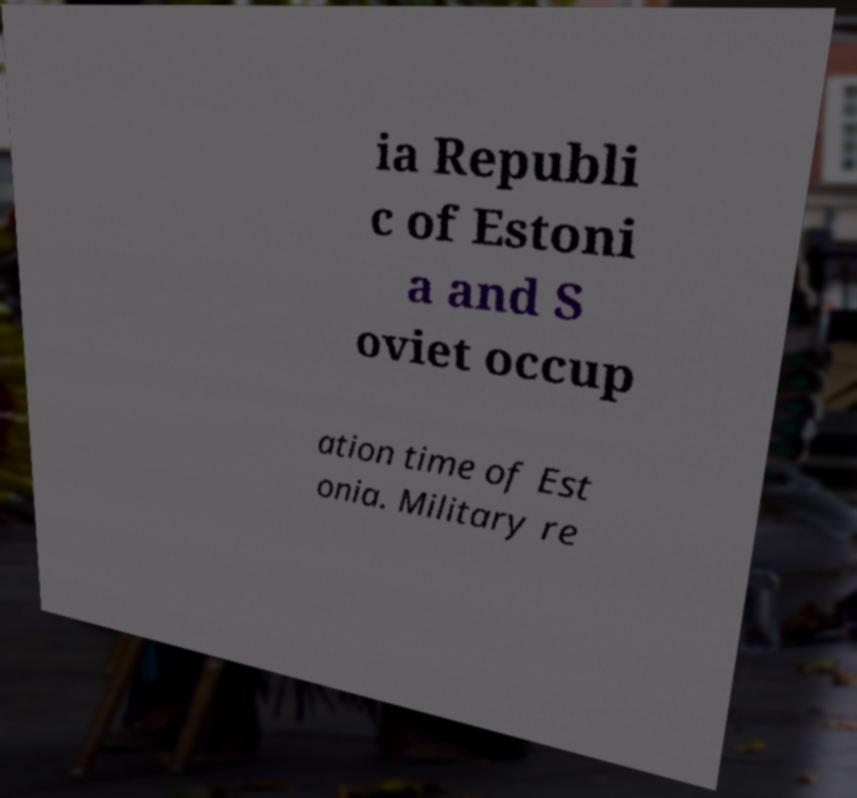For documentation purposes, I need the text within this image transcribed. Could you provide that? ia Republi c of Estoni a and S oviet occup ation time of Est onia. Military re 